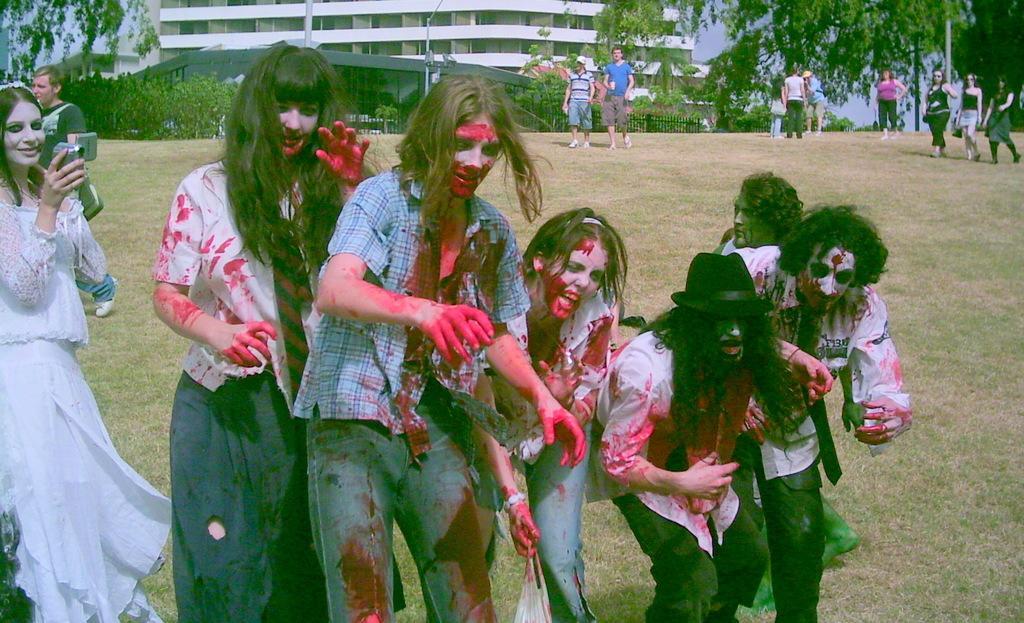Could you give a brief overview of what you see in this image? In this picture I can observe some people on the land who are in halloween makeup. In the background there are some people walking on the land. I can observe plants and a building in the background. 